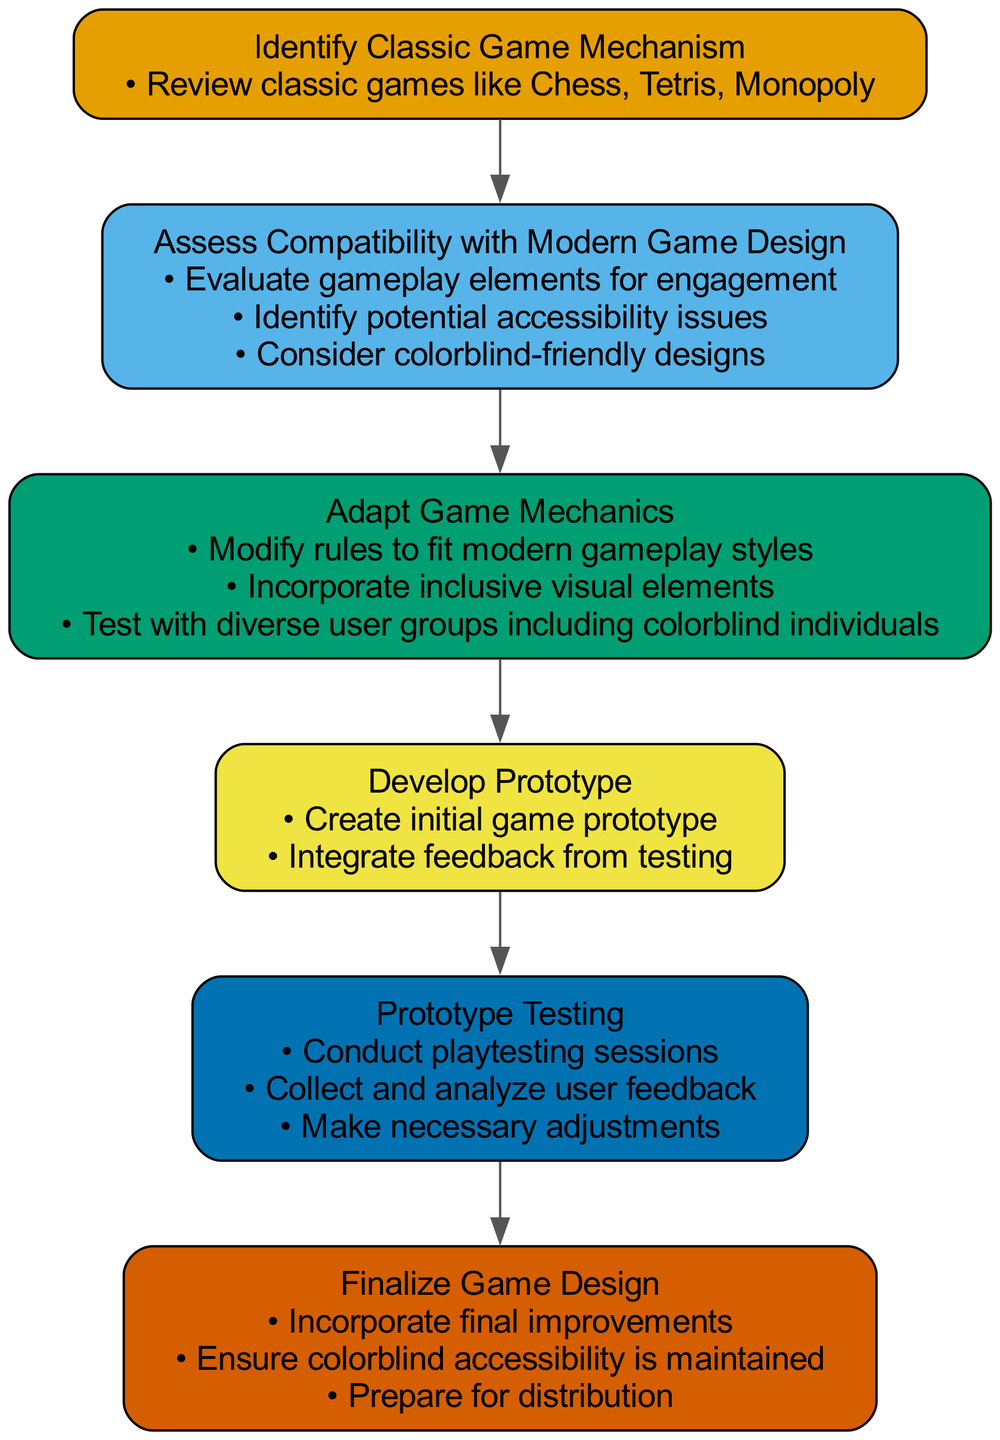What is the first step in the clinical pathway? The diagram starts with a node labeled "Identify Classic Game Mechanism," which indicates this is the first step.
Answer: Identify Classic Game Mechanism How many tasks are in the "Assess Compatibility with Modern Game Design" node? The "Assess Compatibility with Modern Game Design" node contains three tasks, as indicated by the bullet points under that node.
Answer: 3 What is the final node in the clinical pathway? The final node in the pathway is labeled "Finalize Game Design," representing the last step in the process.
Answer: Finalize Game Design Which node includes testing with colorblind individuals? The node for "Adapt Game Mechanics" describes the need to test with diverse user groups, specifically mentioning colorblind individuals.
Answer: Adapt Game Mechanics How many edges connect the "Prototype Development" node? The "Prototype Development" node has two edges connecting it to the preceding and following nodes, showing its position in the pathway.
Answer: 2 Which task focuses on integrating feedback? The second task in the "Develop Prototype" node focuses on integrating feedback from testing, as indicated in the bullet points.
Answer: Integrate feedback from testing What step involves evaluating gameplay elements? The first task in the "Assess Compatibility with Modern Game Design" node is to evaluate gameplay elements for engagement.
Answer: Evaluate gameplay elements for engagement What does the second task of the "Finalize Game Design" involve? The second task of the "Finalize Game Design" node ensures that colorblind accessibility is maintained, specifically addressing accessibility needs.
Answer: Ensure colorblind accessibility is maintained 